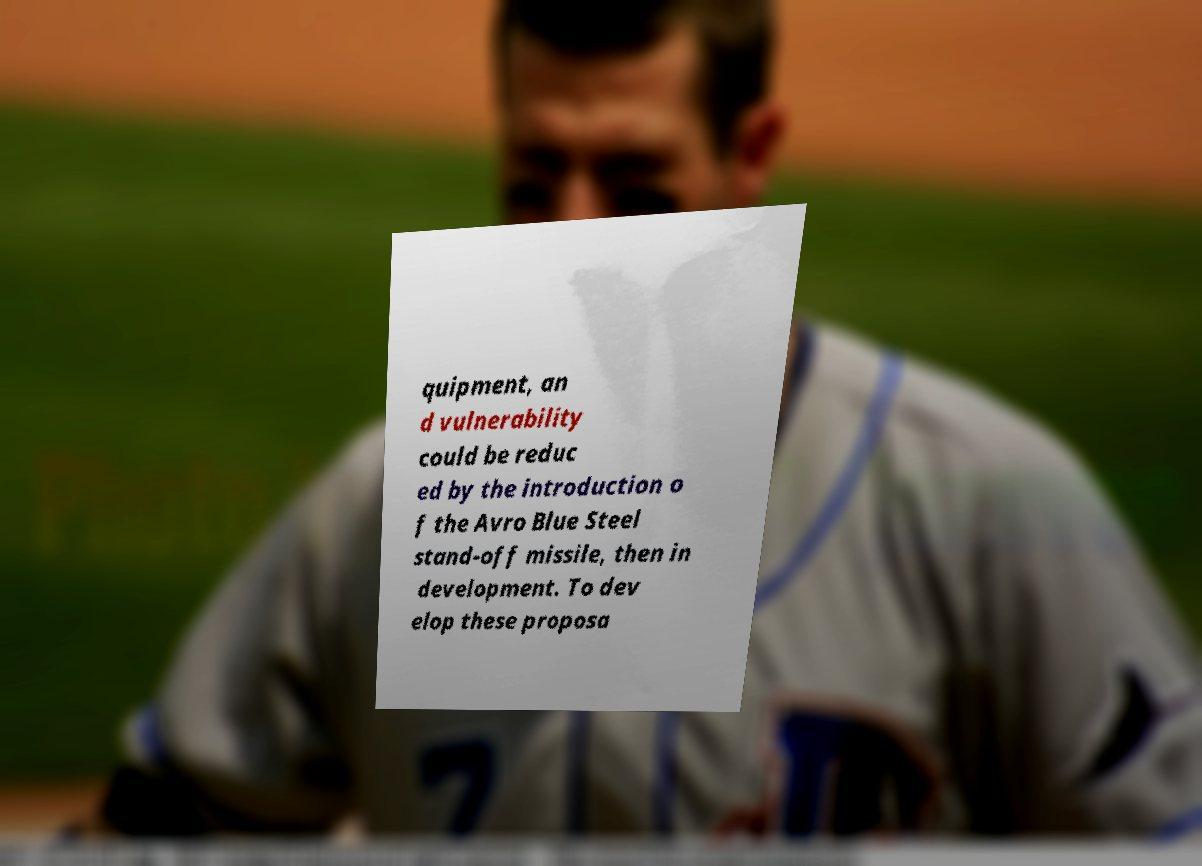Could you assist in decoding the text presented in this image and type it out clearly? quipment, an d vulnerability could be reduc ed by the introduction o f the Avro Blue Steel stand-off missile, then in development. To dev elop these proposa 